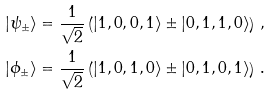Convert formula to latex. <formula><loc_0><loc_0><loc_500><loc_500>| \psi _ { \pm } \rangle & = \frac { 1 } { \sqrt { 2 } } \left ( | 1 , 0 , 0 , 1 \rangle \pm | 0 , 1 , 1 , 0 \rangle \right ) \, , \\ | \phi _ { \pm } \rangle & = \frac { 1 } { \sqrt { 2 } } \left ( | 1 , 0 , 1 , 0 \rangle \pm | 0 , 1 , 0 , 1 \rangle \right ) \, .</formula> 